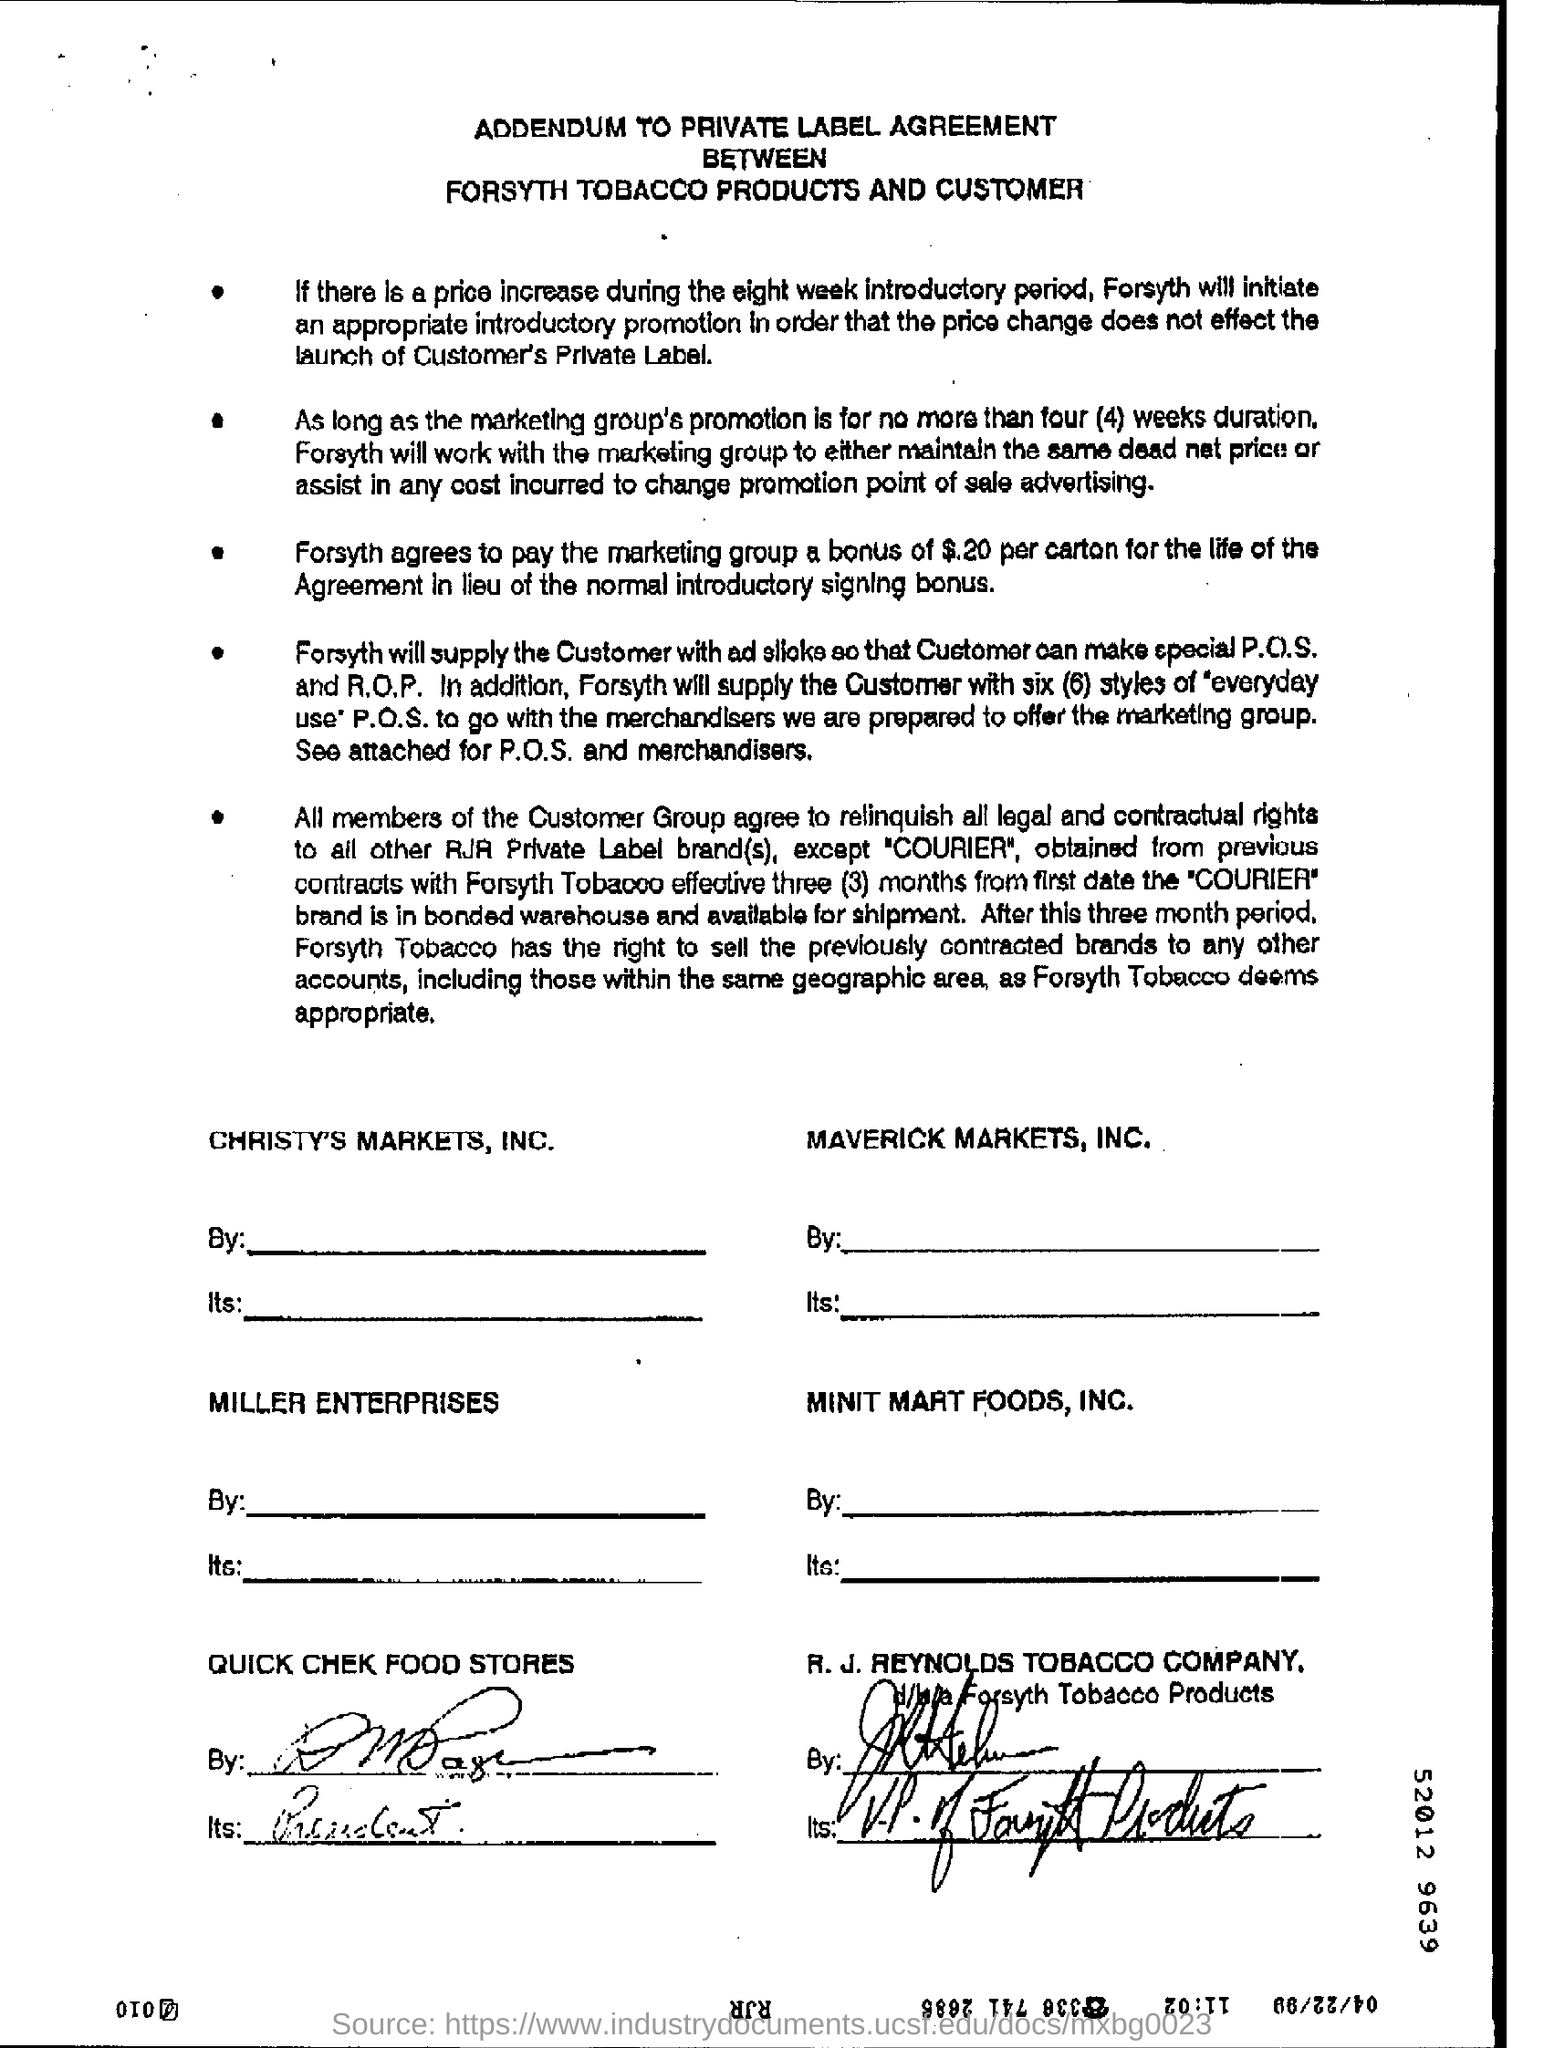What is the heading of the document?
Provide a short and direct response. Addendum to private label agreement. What will happen if there is a price increase during the eight week Introductory period?
Keep it short and to the point. Forsyth will initiate an appropriate introductory promotion in order that the price change does not effect the launch of Customer's private label. What is the duration of the promotion?
Give a very brief answer. No more than four (4) weeks duration. How many styles of P.O.S. will the Forsyth supply?
Ensure brevity in your answer.  Six. 